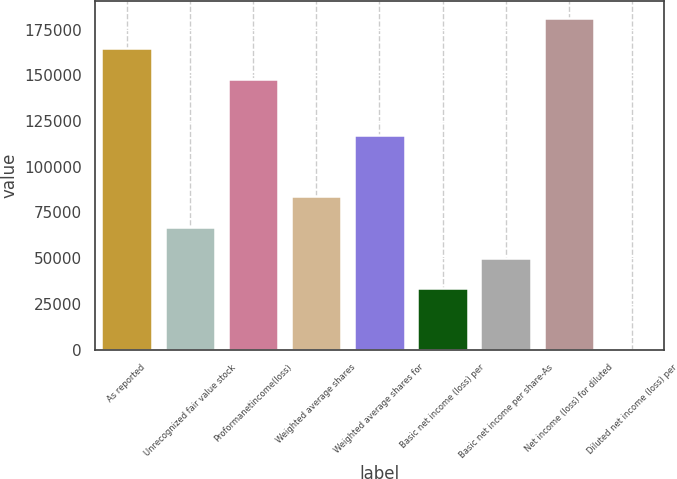<chart> <loc_0><loc_0><loc_500><loc_500><bar_chart><fcel>As reported<fcel>Unrecognized fair value stock<fcel>Proformanetincome(loss)<fcel>Weighted average shares<fcel>Weighted average shares for<fcel>Basic net income (loss) per<fcel>Basic net income per share-As<fcel>Net income (loss) for diluted<fcel>Diluted net income (loss) per<nl><fcel>164656<fcel>67025.5<fcel>147900<fcel>83781.4<fcel>117293<fcel>33513.7<fcel>50269.6<fcel>181412<fcel>1.83<nl></chart> 